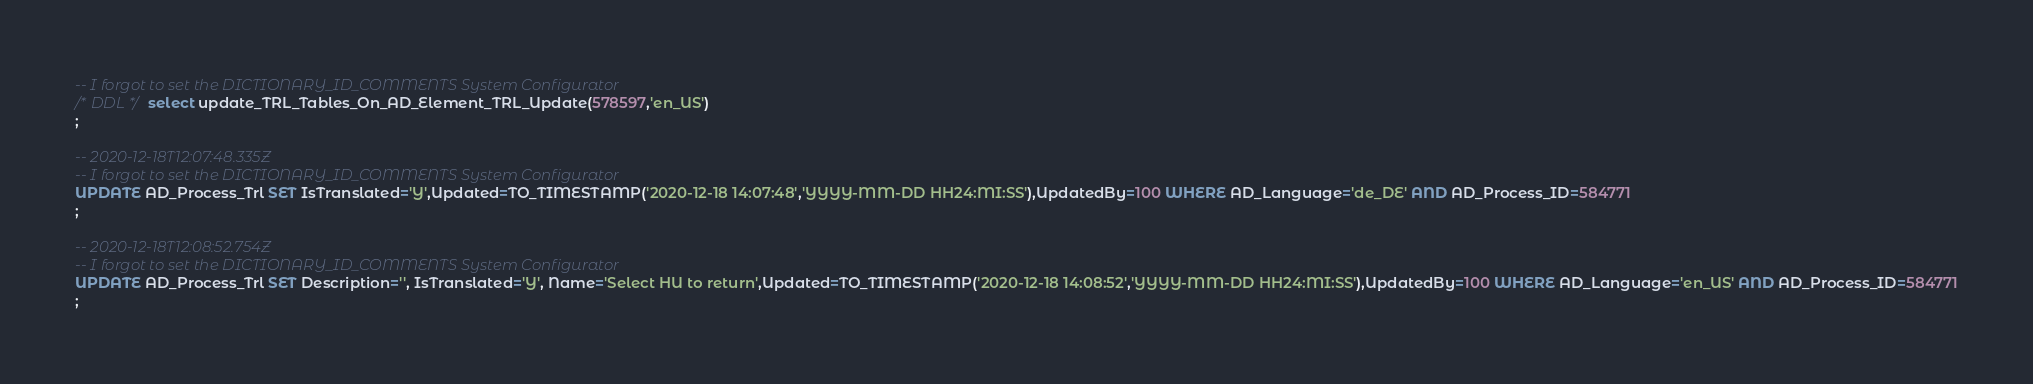<code> <loc_0><loc_0><loc_500><loc_500><_SQL_>-- I forgot to set the DICTIONARY_ID_COMMENTS System Configurator
/* DDL */  select update_TRL_Tables_On_AD_Element_TRL_Update(578597,'en_US') 
;

-- 2020-12-18T12:07:48.335Z
-- I forgot to set the DICTIONARY_ID_COMMENTS System Configurator
UPDATE AD_Process_Trl SET IsTranslated='Y',Updated=TO_TIMESTAMP('2020-12-18 14:07:48','YYYY-MM-DD HH24:MI:SS'),UpdatedBy=100 WHERE AD_Language='de_DE' AND AD_Process_ID=584771
;

-- 2020-12-18T12:08:52.754Z
-- I forgot to set the DICTIONARY_ID_COMMENTS System Configurator
UPDATE AD_Process_Trl SET Description='', IsTranslated='Y', Name='Select HU to return',Updated=TO_TIMESTAMP('2020-12-18 14:08:52','YYYY-MM-DD HH24:MI:SS'),UpdatedBy=100 WHERE AD_Language='en_US' AND AD_Process_ID=584771
;

</code> 